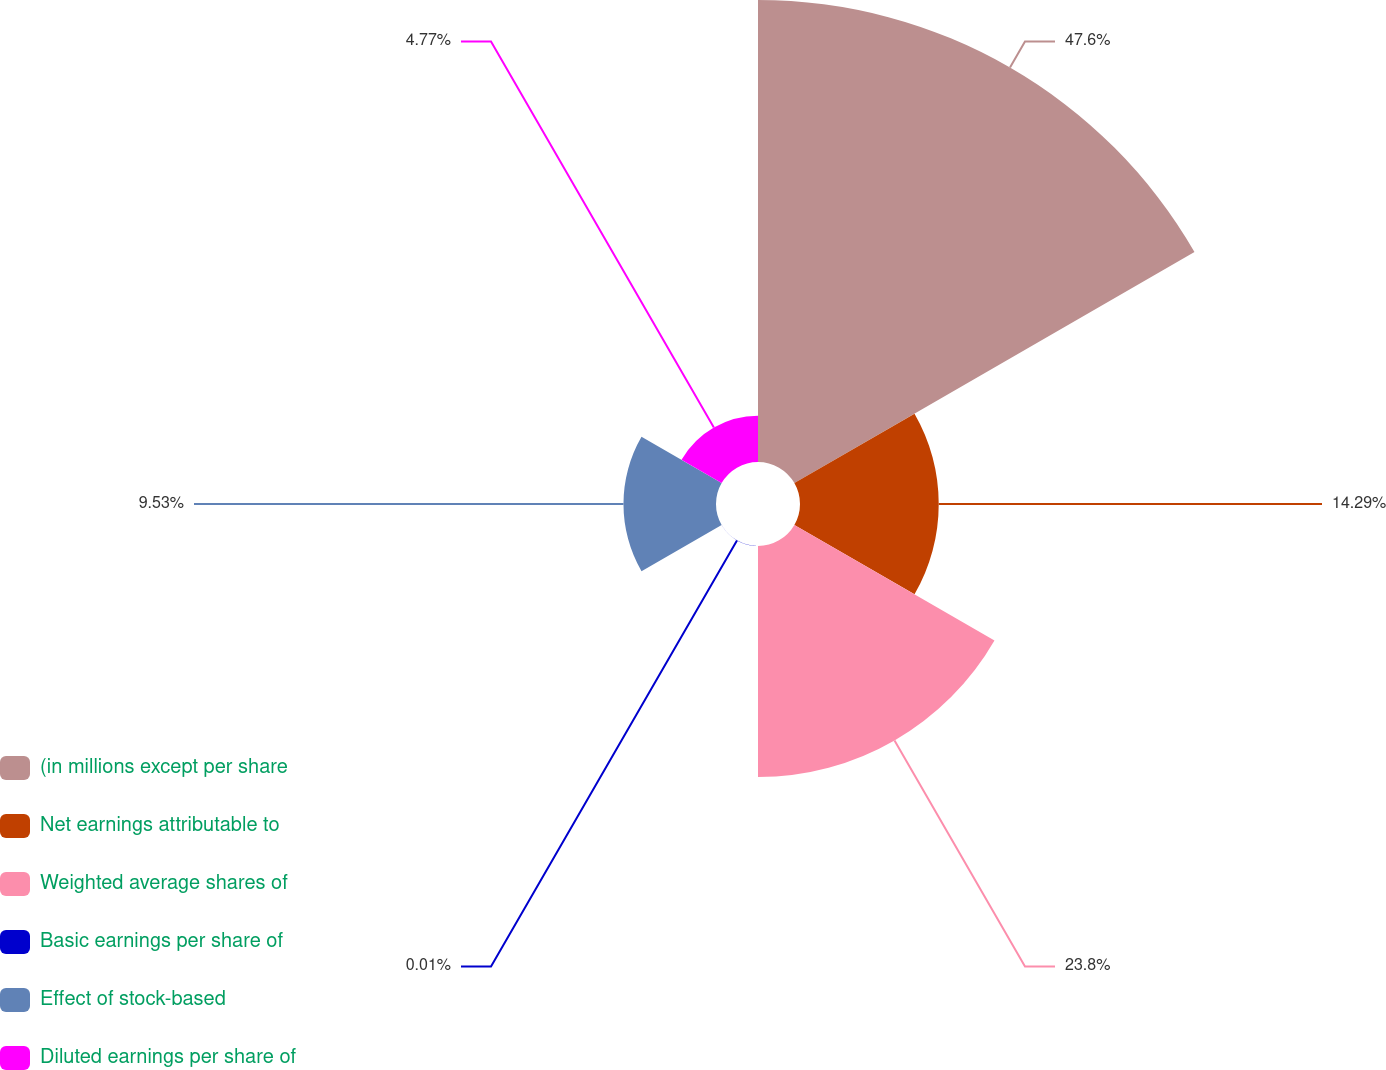Convert chart to OTSL. <chart><loc_0><loc_0><loc_500><loc_500><pie_chart><fcel>(in millions except per share<fcel>Net earnings attributable to<fcel>Weighted average shares of<fcel>Basic earnings per share of<fcel>Effect of stock-based<fcel>Diluted earnings per share of<nl><fcel>47.59%<fcel>14.29%<fcel>23.8%<fcel>0.01%<fcel>9.53%<fcel>4.77%<nl></chart> 